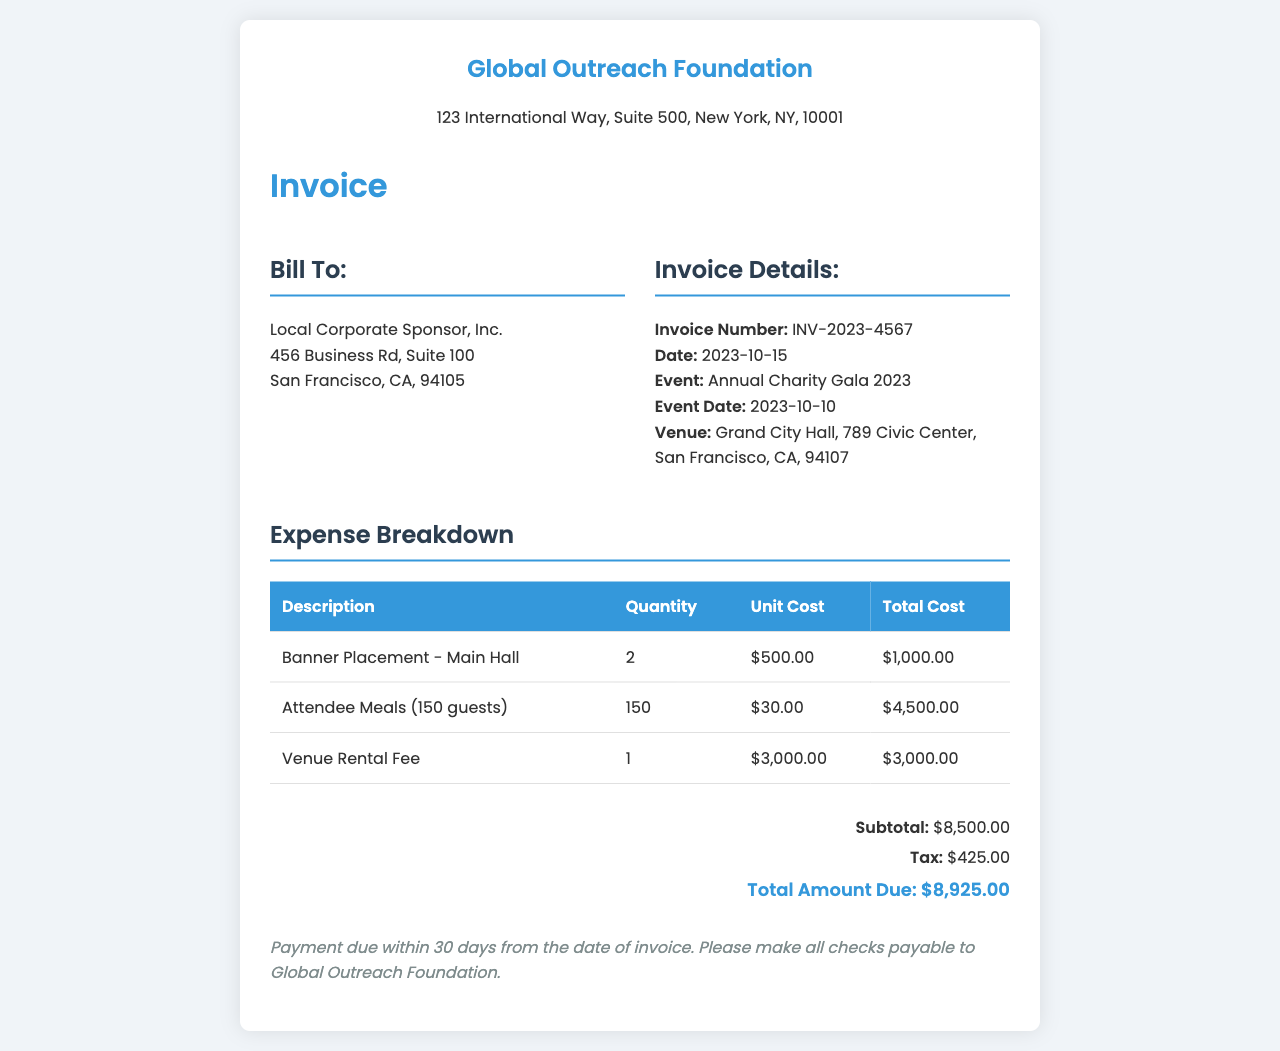what is the invoice number? The invoice number is explicitly stated in the invoice details section, which is INV-2023-4567.
Answer: INV-2023-4567 what is the date of the event? The event date is mentioned in the invoice details section, which is noted as 2023-10-10.
Answer: 2023-10-10 how many attendee meals are included? The document specifies that there are 150 attendee meals included in the expense breakdown.
Answer: 150 what is the total cost for banner placements? The total cost for banner placements can be calculated by looking at the expense breakdown where it states $1,000.00 for 2 placements.
Answer: $1,000.00 what is the subtotal amount? The subtotal amount is presented in the summary section of the invoice, which totals $8,500.00.
Answer: $8,500.00 how much tax is applied? The tax amount is shown in the summary section, which states $425.00.
Answer: $425.00 who is billed for the event? The "Bill To" section explicitly lists the name of the billing party as Local Corporate Sponsor, Inc.
Answer: Local Corporate Sponsor, Inc what is the total amount due? The total amount due is the final figure displayed in the summary section, which is $8,925.00.
Answer: $8,925.00 what is the payment term? The payment term is stated in the payment terms section, which specifies payment due within 30 days from the date of invoice.
Answer: 30 days 